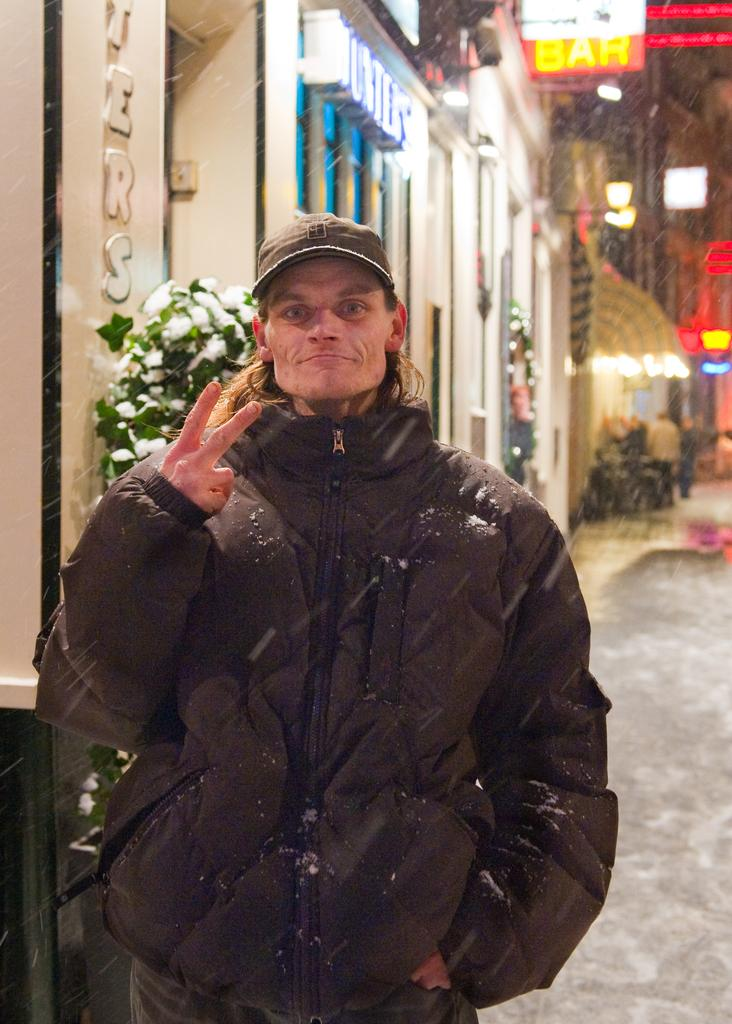What is the main subject of the image? The main subject of the image is a man standing. What is the man wearing in the image? The man is wearing a jacket and a cap in the image. What can be seen in the background of the image? There are buildings visible in the background of the image. What type of soup is being cooked on the canvas in the image? There is no soup or canvas present in the image; it features a man standing and wearing a jacket and cap, with buildings visible in the background. 